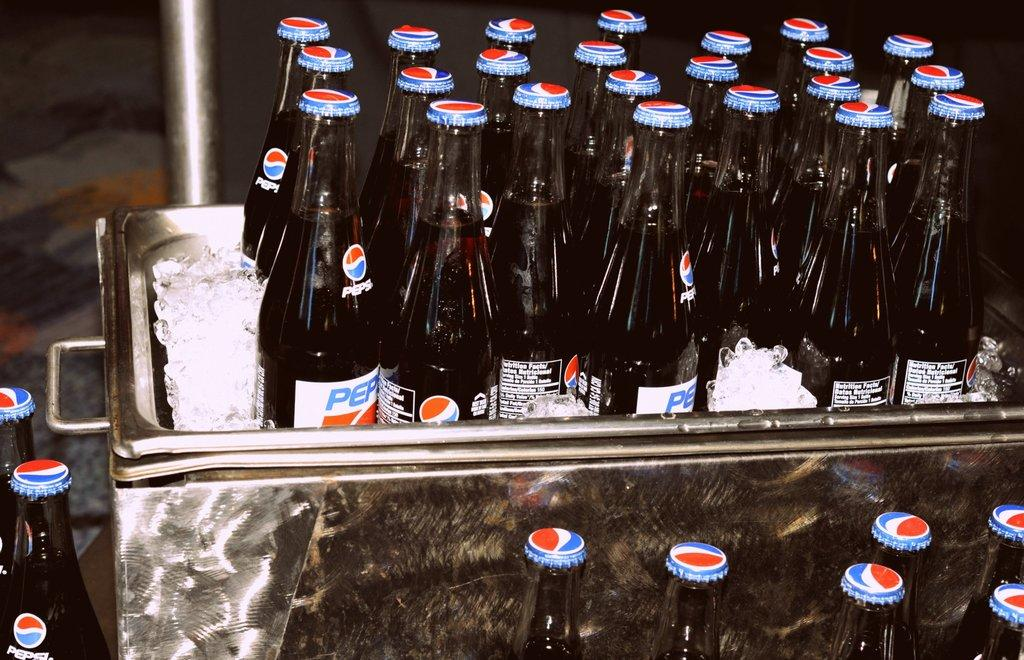<image>
Provide a brief description of the given image. A lot of Pepsi bottles cooling in a tub of ice 